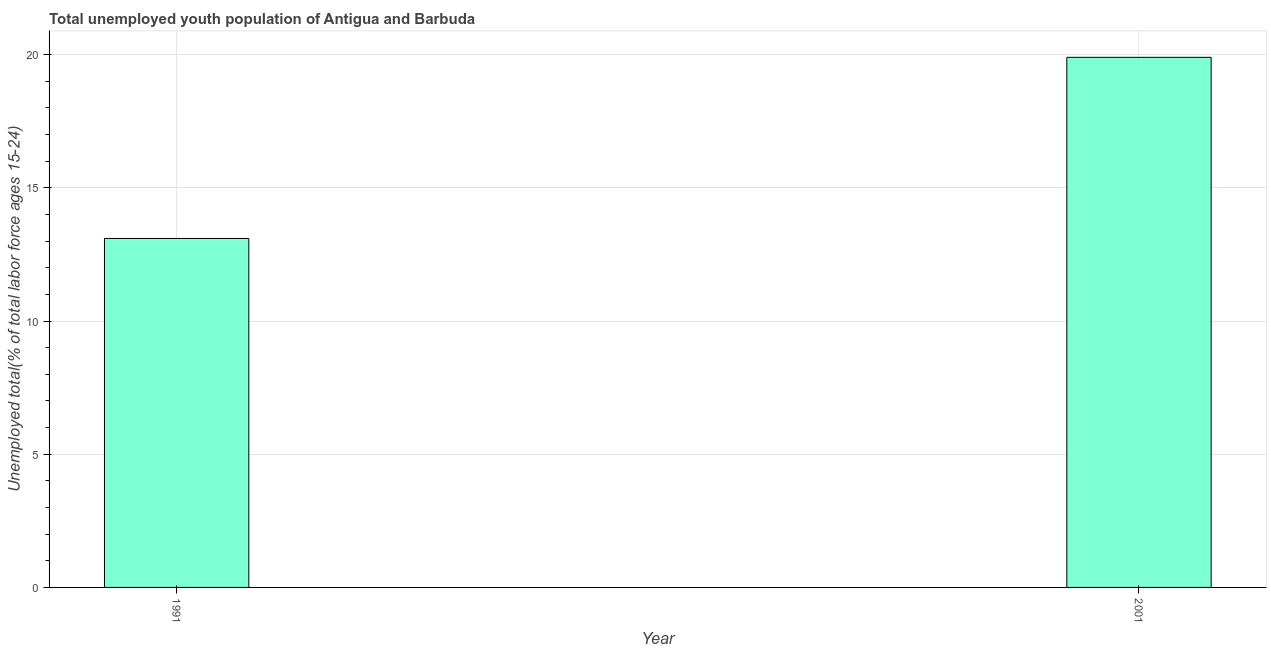Does the graph contain any zero values?
Keep it short and to the point. No. Does the graph contain grids?
Your answer should be very brief. Yes. What is the title of the graph?
Your answer should be very brief. Total unemployed youth population of Antigua and Barbuda. What is the label or title of the Y-axis?
Offer a very short reply. Unemployed total(% of total labor force ages 15-24). What is the unemployed youth in 2001?
Keep it short and to the point. 19.9. Across all years, what is the maximum unemployed youth?
Your response must be concise. 19.9. Across all years, what is the minimum unemployed youth?
Make the answer very short. 13.1. In which year was the unemployed youth maximum?
Your answer should be very brief. 2001. In which year was the unemployed youth minimum?
Give a very brief answer. 1991. What is the difference between the unemployed youth in 1991 and 2001?
Your response must be concise. -6.8. What is the average unemployed youth per year?
Offer a terse response. 16.5. What is the ratio of the unemployed youth in 1991 to that in 2001?
Give a very brief answer. 0.66. Is the unemployed youth in 1991 less than that in 2001?
Your answer should be very brief. Yes. How many bars are there?
Give a very brief answer. 2. Are all the bars in the graph horizontal?
Ensure brevity in your answer.  No. How many years are there in the graph?
Your answer should be very brief. 2. Are the values on the major ticks of Y-axis written in scientific E-notation?
Your answer should be compact. No. What is the Unemployed total(% of total labor force ages 15-24) of 1991?
Keep it short and to the point. 13.1. What is the Unemployed total(% of total labor force ages 15-24) of 2001?
Your response must be concise. 19.9. What is the difference between the Unemployed total(% of total labor force ages 15-24) in 1991 and 2001?
Your answer should be compact. -6.8. What is the ratio of the Unemployed total(% of total labor force ages 15-24) in 1991 to that in 2001?
Keep it short and to the point. 0.66. 